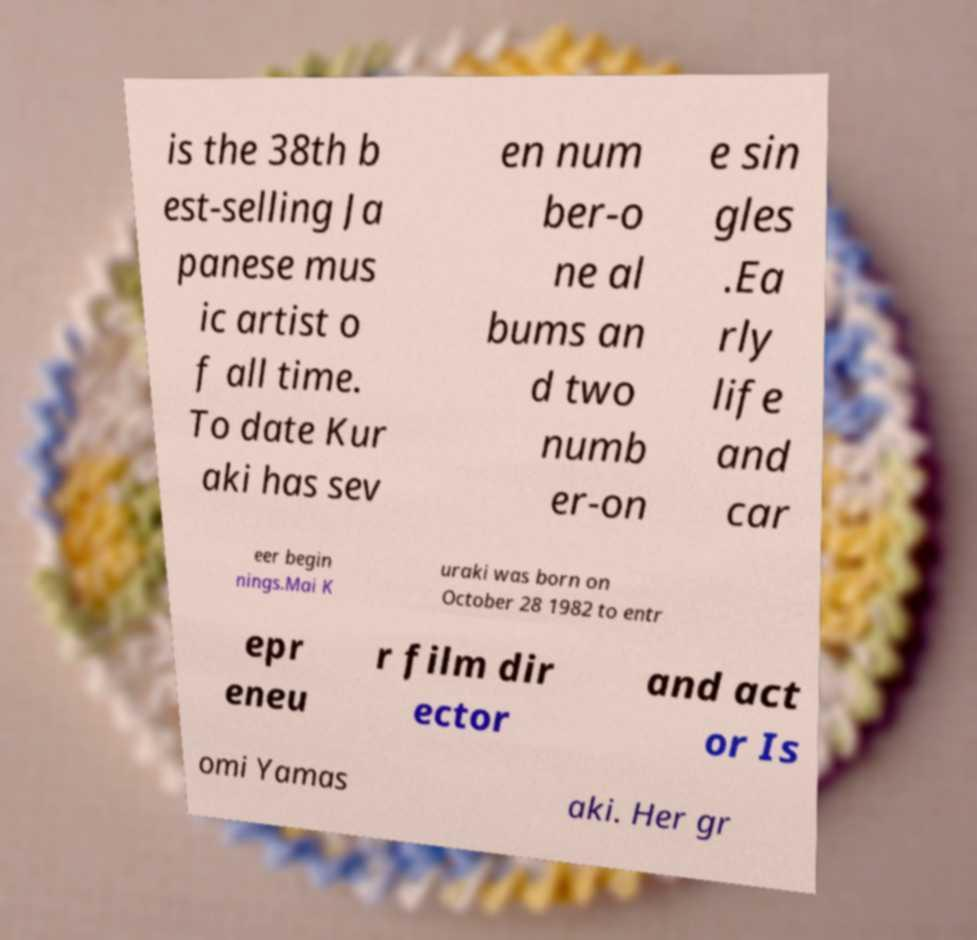Could you extract and type out the text from this image? is the 38th b est-selling Ja panese mus ic artist o f all time. To date Kur aki has sev en num ber-o ne al bums an d two numb er-on e sin gles .Ea rly life and car eer begin nings.Mai K uraki was born on October 28 1982 to entr epr eneu r film dir ector and act or Is omi Yamas aki. Her gr 